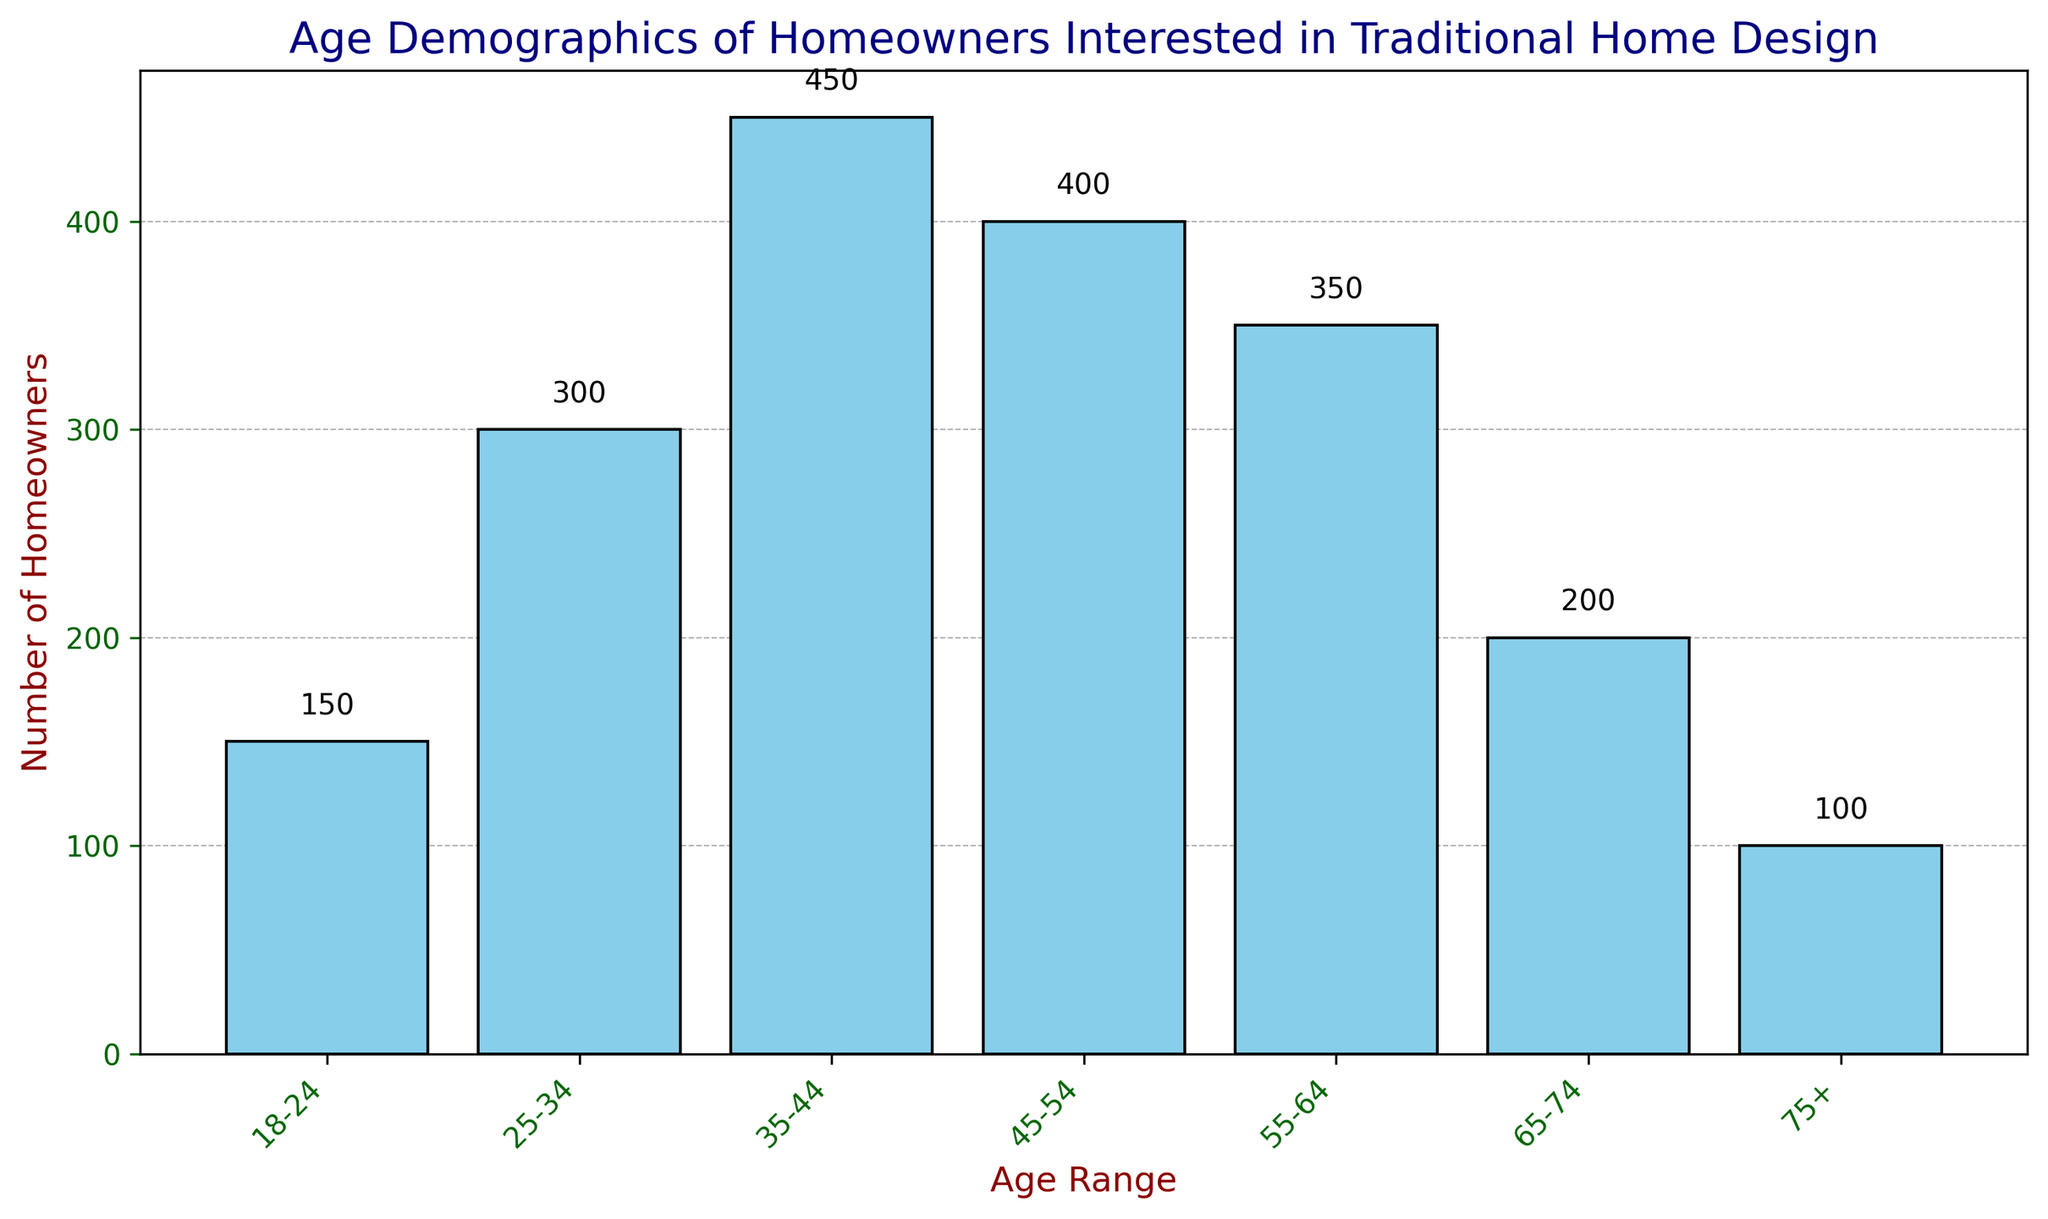What's the age group with the highest number of homeowners interested in traditional home design? The age group with the highest bar represents the highest number of homeowners. In this chart, the age range 35-44 has the tallest bar, indicating the highest number.
Answer: 35-44 Which age group shows a decreasing trend in the number of homeowners compared to the age group immediately before it? By examining each bar, the age groups 45-54 to 55-64, 65-74 to 75+ show a decrease in height, indicating a lower number of homeowners compared to the previous age group.
Answer: 55-64 and 75+ What is the total number of homeowners interested in traditional home design in the 18-34 age group? Sum the number of homeowners in the 18-24 and 25-34 age groups: 150 + 300 = 450.
Answer: 450 What's the difference in the number of homeowners between the age groups 45-54 and 75+? Subtract the number of homeowners in the 75+ age group from the 45-54 age group: 400 - 100 = 300.
Answer: 300 What is the average number of homeowners across all age groups? Sum all the number of homeowners and divide by the number of age groups: (150 + 300 + 450 + 400 + 350 + 200 + 100) / 7 ≈ 278.57.
Answer: 278.57 How much greater is the number of homeowners in the age group 35-44 compared to the 18-24 age group? Subtract the number of homeowners in the 18-24 age group from the 35-44 age group: 450 - 150 = 300.
Answer: 300 Which age group has the lowest number of homeowners interested in traditional home design? The shortest bar indicates the lowest number of homeowners, which is in the 75+ age group.
Answer: 75+ What is the combined number of homeowners in age ranges 55-64 and 65-74? Add the number of homeowners in the age ranges 55-64 and 65-74: 350 + 200 = 550.
Answer: 550 Is the number of homeowners aged 45-54 greater or less than the number of homeowners aged 55-64? Compare the height of the bars for age groups 45-54 and 55-64. The bar for 45-54 is taller, indicating a greater number of homeowners.
Answer: Greater What is the median number of homeowners among all age groups? List the number of homeowners in ascending order: 100, 150, 200, 300, 350, 400, 450. The median value is the middle number: 300.
Answer: 300 